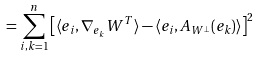Convert formula to latex. <formula><loc_0><loc_0><loc_500><loc_500>= \sum _ { i , k = 1 } ^ { n } \left [ \langle e _ { i } , \nabla _ { e _ { k } } W ^ { T } \rangle - \langle e _ { i } , A _ { W ^ { \perp } } ( e _ { k } ) \rangle \right ] ^ { 2 }</formula> 